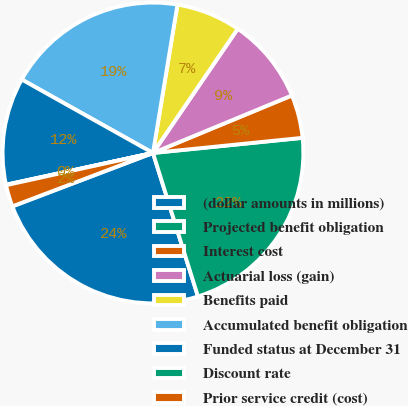Convert chart. <chart><loc_0><loc_0><loc_500><loc_500><pie_chart><fcel>(dollar amounts in millions)<fcel>Projected benefit obligation<fcel>Interest cost<fcel>Actuarial loss (gain)<fcel>Benefits paid<fcel>Accumulated benefit obligation<fcel>Funded status at December 31<fcel>Discount rate<fcel>Prior service credit (cost)<nl><fcel>24.06%<fcel>21.77%<fcel>4.64%<fcel>9.22%<fcel>6.93%<fcel>19.48%<fcel>11.51%<fcel>0.05%<fcel>2.34%<nl></chart> 